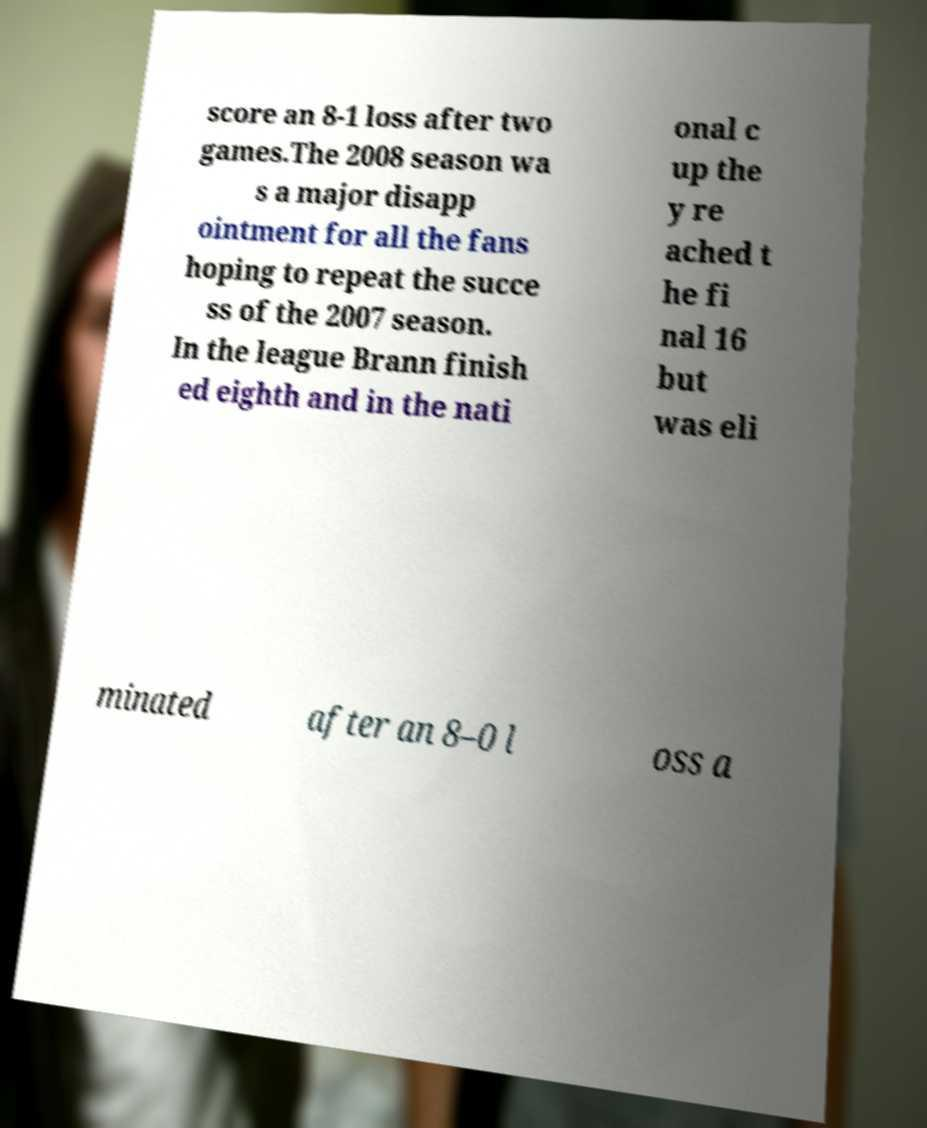For documentation purposes, I need the text within this image transcribed. Could you provide that? score an 8-1 loss after two games.The 2008 season wa s a major disapp ointment for all the fans hoping to repeat the succe ss of the 2007 season. In the league Brann finish ed eighth and in the nati onal c up the y re ached t he fi nal 16 but was eli minated after an 8–0 l oss a 